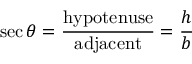<formula> <loc_0><loc_0><loc_500><loc_500>\sec \theta = { \frac { h y p o t e n u s e } { a d j a c e n t } } = { \frac { h } { b } }</formula> 